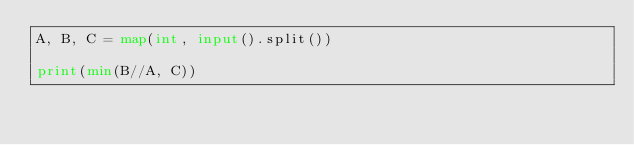Convert code to text. <code><loc_0><loc_0><loc_500><loc_500><_Python_>A, B, C = map(int, input().split())

print(min(B//A, C))
</code> 